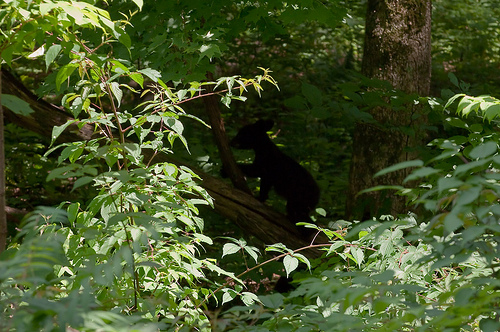<image>
Is the animal on the tree? Yes. Looking at the image, I can see the animal is positioned on top of the tree, with the tree providing support. 